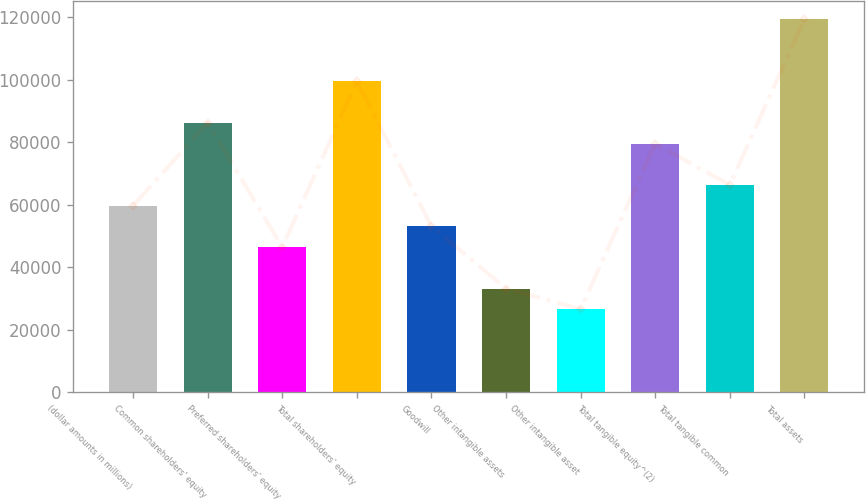Convert chart. <chart><loc_0><loc_0><loc_500><loc_500><bar_chart><fcel>(dollar amounts in millions)<fcel>Common shareholders' equity<fcel>Preferred shareholders' equity<fcel>Total shareholders' equity<fcel>Goodwill<fcel>Other intangible assets<fcel>Other intangible asset<fcel>Total tangible equity^(2)<fcel>Total tangible common<fcel>Total assets<nl><fcel>59669<fcel>86184.9<fcel>46411<fcel>99442.9<fcel>53040<fcel>33153.1<fcel>26524.1<fcel>79555.9<fcel>66298<fcel>119330<nl></chart> 